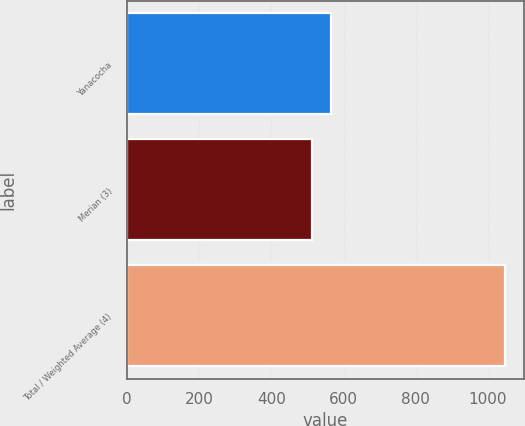Convert chart to OTSL. <chart><loc_0><loc_0><loc_500><loc_500><bar_chart><fcel>Yanacocha<fcel>Merian (3)<fcel>Total / Weighted Average (4)<nl><fcel>566.5<fcel>513<fcel>1048<nl></chart> 